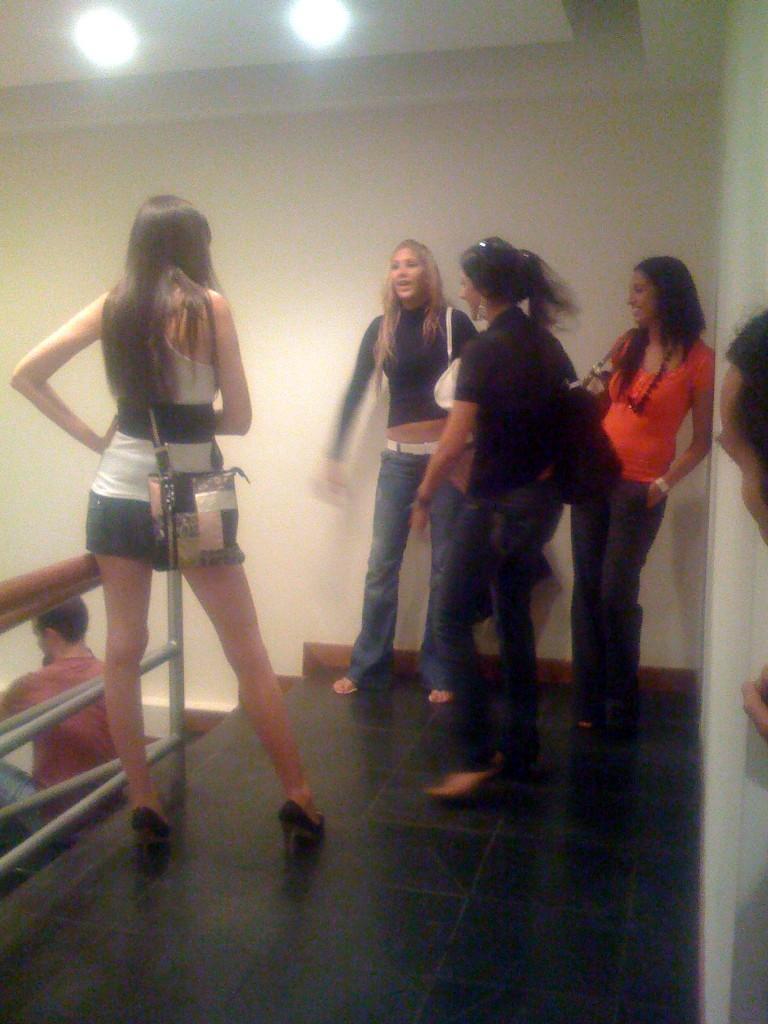Could you give a brief overview of what you see in this image? In this image I can see group of people standing. The person in front wearing black and white dress and white color bag. Background I can see wall in cream color, two lights and I can see a person sitting on the stairs. 